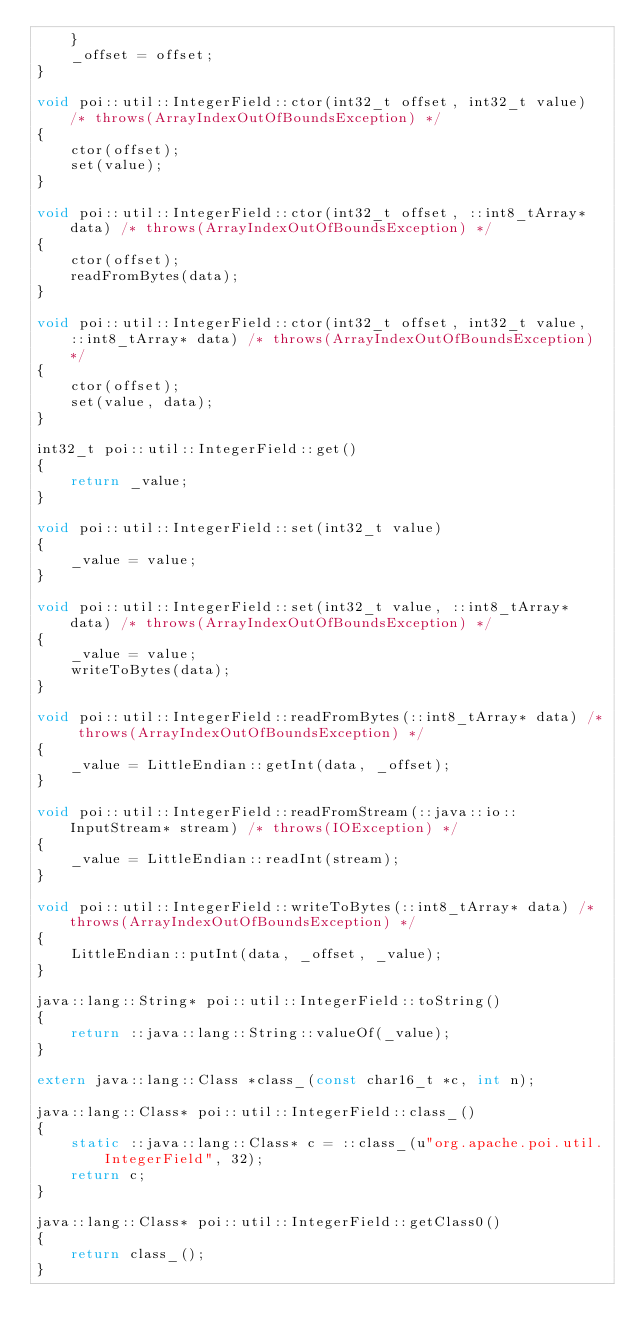Convert code to text. <code><loc_0><loc_0><loc_500><loc_500><_C++_>    }
    _offset = offset;
}

void poi::util::IntegerField::ctor(int32_t offset, int32_t value) /* throws(ArrayIndexOutOfBoundsException) */
{
    ctor(offset);
    set(value);
}

void poi::util::IntegerField::ctor(int32_t offset, ::int8_tArray* data) /* throws(ArrayIndexOutOfBoundsException) */
{
    ctor(offset);
    readFromBytes(data);
}

void poi::util::IntegerField::ctor(int32_t offset, int32_t value, ::int8_tArray* data) /* throws(ArrayIndexOutOfBoundsException) */
{
    ctor(offset);
    set(value, data);
}

int32_t poi::util::IntegerField::get()
{
    return _value;
}

void poi::util::IntegerField::set(int32_t value)
{
    _value = value;
}

void poi::util::IntegerField::set(int32_t value, ::int8_tArray* data) /* throws(ArrayIndexOutOfBoundsException) */
{
    _value = value;
    writeToBytes(data);
}

void poi::util::IntegerField::readFromBytes(::int8_tArray* data) /* throws(ArrayIndexOutOfBoundsException) */
{
    _value = LittleEndian::getInt(data, _offset);
}

void poi::util::IntegerField::readFromStream(::java::io::InputStream* stream) /* throws(IOException) */
{
    _value = LittleEndian::readInt(stream);
}

void poi::util::IntegerField::writeToBytes(::int8_tArray* data) /* throws(ArrayIndexOutOfBoundsException) */
{
    LittleEndian::putInt(data, _offset, _value);
}

java::lang::String* poi::util::IntegerField::toString()
{
    return ::java::lang::String::valueOf(_value);
}

extern java::lang::Class *class_(const char16_t *c, int n);

java::lang::Class* poi::util::IntegerField::class_()
{
    static ::java::lang::Class* c = ::class_(u"org.apache.poi.util.IntegerField", 32);
    return c;
}

java::lang::Class* poi::util::IntegerField::getClass0()
{
    return class_();
}

</code> 